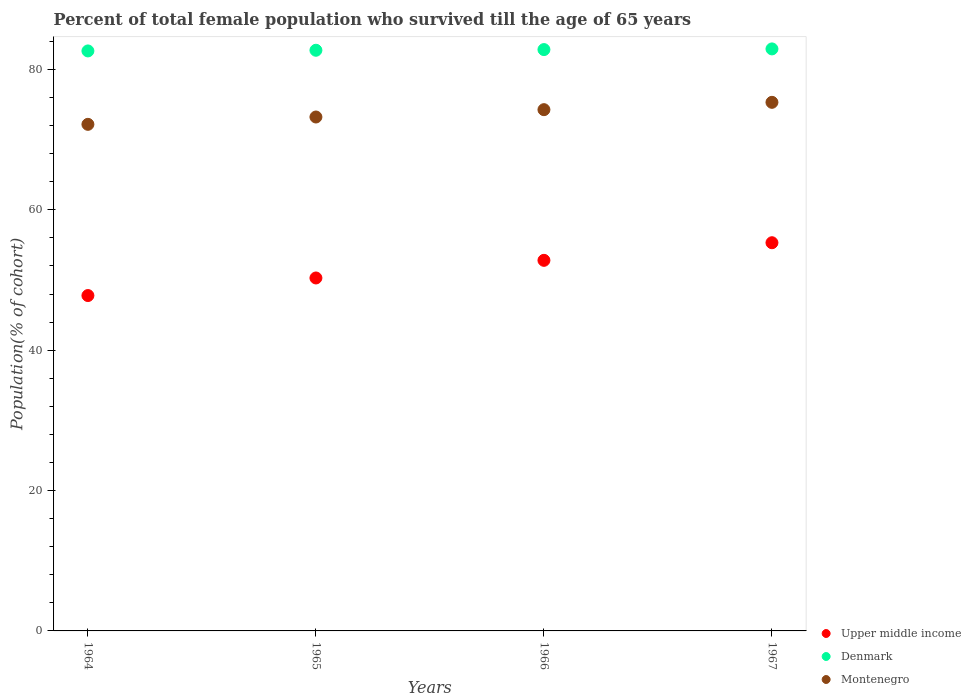How many different coloured dotlines are there?
Offer a very short reply. 3. What is the percentage of total female population who survived till the age of 65 years in Denmark in 1965?
Your answer should be very brief. 82.73. Across all years, what is the maximum percentage of total female population who survived till the age of 65 years in Denmark?
Offer a very short reply. 82.92. Across all years, what is the minimum percentage of total female population who survived till the age of 65 years in Denmark?
Your answer should be very brief. 82.63. In which year was the percentage of total female population who survived till the age of 65 years in Montenegro maximum?
Your answer should be very brief. 1967. In which year was the percentage of total female population who survived till the age of 65 years in Montenegro minimum?
Your answer should be very brief. 1964. What is the total percentage of total female population who survived till the age of 65 years in Denmark in the graph?
Make the answer very short. 331.11. What is the difference between the percentage of total female population who survived till the age of 65 years in Montenegro in 1966 and that in 1967?
Your answer should be very brief. -1.05. What is the difference between the percentage of total female population who survived till the age of 65 years in Upper middle income in 1966 and the percentage of total female population who survived till the age of 65 years in Montenegro in 1964?
Give a very brief answer. -19.38. What is the average percentage of total female population who survived till the age of 65 years in Upper middle income per year?
Give a very brief answer. 51.54. In the year 1964, what is the difference between the percentage of total female population who survived till the age of 65 years in Montenegro and percentage of total female population who survived till the age of 65 years in Upper middle income?
Ensure brevity in your answer.  24.39. In how many years, is the percentage of total female population who survived till the age of 65 years in Denmark greater than 32 %?
Keep it short and to the point. 4. What is the ratio of the percentage of total female population who survived till the age of 65 years in Montenegro in 1964 to that in 1967?
Keep it short and to the point. 0.96. Is the percentage of total female population who survived till the age of 65 years in Denmark in 1965 less than that in 1966?
Offer a very short reply. Yes. Is the difference between the percentage of total female population who survived till the age of 65 years in Montenegro in 1964 and 1967 greater than the difference between the percentage of total female population who survived till the age of 65 years in Upper middle income in 1964 and 1967?
Provide a succinct answer. Yes. What is the difference between the highest and the second highest percentage of total female population who survived till the age of 65 years in Montenegro?
Give a very brief answer. 1.05. What is the difference between the highest and the lowest percentage of total female population who survived till the age of 65 years in Montenegro?
Give a very brief answer. 3.14. Is it the case that in every year, the sum of the percentage of total female population who survived till the age of 65 years in Denmark and percentage of total female population who survived till the age of 65 years in Montenegro  is greater than the percentage of total female population who survived till the age of 65 years in Upper middle income?
Your answer should be compact. Yes. How many dotlines are there?
Keep it short and to the point. 3. How many years are there in the graph?
Keep it short and to the point. 4. What is the difference between two consecutive major ticks on the Y-axis?
Keep it short and to the point. 20. Does the graph contain grids?
Offer a terse response. No. How many legend labels are there?
Offer a terse response. 3. How are the legend labels stacked?
Keep it short and to the point. Vertical. What is the title of the graph?
Provide a succinct answer. Percent of total female population who survived till the age of 65 years. What is the label or title of the X-axis?
Your answer should be compact. Years. What is the label or title of the Y-axis?
Offer a terse response. Population(% of cohort). What is the Population(% of cohort) of Upper middle income in 1964?
Your response must be concise. 47.78. What is the Population(% of cohort) of Denmark in 1964?
Give a very brief answer. 82.63. What is the Population(% of cohort) in Montenegro in 1964?
Make the answer very short. 72.17. What is the Population(% of cohort) of Upper middle income in 1965?
Offer a terse response. 50.29. What is the Population(% of cohort) in Denmark in 1965?
Keep it short and to the point. 82.73. What is the Population(% of cohort) in Montenegro in 1965?
Offer a very short reply. 73.22. What is the Population(% of cohort) of Upper middle income in 1966?
Your answer should be very brief. 52.8. What is the Population(% of cohort) of Denmark in 1966?
Make the answer very short. 82.82. What is the Population(% of cohort) in Montenegro in 1966?
Provide a short and direct response. 74.26. What is the Population(% of cohort) in Upper middle income in 1967?
Offer a terse response. 55.31. What is the Population(% of cohort) of Denmark in 1967?
Give a very brief answer. 82.92. What is the Population(% of cohort) in Montenegro in 1967?
Make the answer very short. 75.31. Across all years, what is the maximum Population(% of cohort) in Upper middle income?
Provide a succinct answer. 55.31. Across all years, what is the maximum Population(% of cohort) in Denmark?
Your answer should be compact. 82.92. Across all years, what is the maximum Population(% of cohort) in Montenegro?
Give a very brief answer. 75.31. Across all years, what is the minimum Population(% of cohort) of Upper middle income?
Give a very brief answer. 47.78. Across all years, what is the minimum Population(% of cohort) in Denmark?
Provide a succinct answer. 82.63. Across all years, what is the minimum Population(% of cohort) of Montenegro?
Offer a terse response. 72.17. What is the total Population(% of cohort) of Upper middle income in the graph?
Provide a succinct answer. 206.17. What is the total Population(% of cohort) in Denmark in the graph?
Provide a succinct answer. 331.11. What is the total Population(% of cohort) in Montenegro in the graph?
Provide a short and direct response. 294.97. What is the difference between the Population(% of cohort) of Upper middle income in 1964 and that in 1965?
Give a very brief answer. -2.5. What is the difference between the Population(% of cohort) of Denmark in 1964 and that in 1965?
Your answer should be very brief. -0.1. What is the difference between the Population(% of cohort) in Montenegro in 1964 and that in 1965?
Make the answer very short. -1.05. What is the difference between the Population(% of cohort) of Upper middle income in 1964 and that in 1966?
Make the answer very short. -5.02. What is the difference between the Population(% of cohort) of Denmark in 1964 and that in 1966?
Your response must be concise. -0.19. What is the difference between the Population(% of cohort) of Montenegro in 1964 and that in 1966?
Give a very brief answer. -2.09. What is the difference between the Population(% of cohort) in Upper middle income in 1964 and that in 1967?
Your answer should be compact. -7.53. What is the difference between the Population(% of cohort) in Denmark in 1964 and that in 1967?
Make the answer very short. -0.29. What is the difference between the Population(% of cohort) of Montenegro in 1964 and that in 1967?
Make the answer very short. -3.14. What is the difference between the Population(% of cohort) of Upper middle income in 1965 and that in 1966?
Ensure brevity in your answer.  -2.51. What is the difference between the Population(% of cohort) in Denmark in 1965 and that in 1966?
Offer a very short reply. -0.1. What is the difference between the Population(% of cohort) in Montenegro in 1965 and that in 1966?
Offer a very short reply. -1.05. What is the difference between the Population(% of cohort) in Upper middle income in 1965 and that in 1967?
Offer a very short reply. -5.02. What is the difference between the Population(% of cohort) of Denmark in 1965 and that in 1967?
Ensure brevity in your answer.  -0.19. What is the difference between the Population(% of cohort) of Montenegro in 1965 and that in 1967?
Keep it short and to the point. -2.09. What is the difference between the Population(% of cohort) in Upper middle income in 1966 and that in 1967?
Keep it short and to the point. -2.51. What is the difference between the Population(% of cohort) of Denmark in 1966 and that in 1967?
Your answer should be compact. -0.1. What is the difference between the Population(% of cohort) of Montenegro in 1966 and that in 1967?
Offer a very short reply. -1.05. What is the difference between the Population(% of cohort) in Upper middle income in 1964 and the Population(% of cohort) in Denmark in 1965?
Provide a short and direct response. -34.95. What is the difference between the Population(% of cohort) of Upper middle income in 1964 and the Population(% of cohort) of Montenegro in 1965?
Provide a succinct answer. -25.44. What is the difference between the Population(% of cohort) of Denmark in 1964 and the Population(% of cohort) of Montenegro in 1965?
Give a very brief answer. 9.41. What is the difference between the Population(% of cohort) of Upper middle income in 1964 and the Population(% of cohort) of Denmark in 1966?
Ensure brevity in your answer.  -35.04. What is the difference between the Population(% of cohort) in Upper middle income in 1964 and the Population(% of cohort) in Montenegro in 1966?
Give a very brief answer. -26.48. What is the difference between the Population(% of cohort) in Denmark in 1964 and the Population(% of cohort) in Montenegro in 1966?
Provide a succinct answer. 8.37. What is the difference between the Population(% of cohort) of Upper middle income in 1964 and the Population(% of cohort) of Denmark in 1967?
Offer a very short reply. -35.14. What is the difference between the Population(% of cohort) in Upper middle income in 1964 and the Population(% of cohort) in Montenegro in 1967?
Your response must be concise. -27.53. What is the difference between the Population(% of cohort) of Denmark in 1964 and the Population(% of cohort) of Montenegro in 1967?
Offer a very short reply. 7.32. What is the difference between the Population(% of cohort) of Upper middle income in 1965 and the Population(% of cohort) of Denmark in 1966?
Offer a very short reply. -32.54. What is the difference between the Population(% of cohort) of Upper middle income in 1965 and the Population(% of cohort) of Montenegro in 1966?
Offer a terse response. -23.98. What is the difference between the Population(% of cohort) of Denmark in 1965 and the Population(% of cohort) of Montenegro in 1966?
Give a very brief answer. 8.46. What is the difference between the Population(% of cohort) of Upper middle income in 1965 and the Population(% of cohort) of Denmark in 1967?
Your answer should be very brief. -32.64. What is the difference between the Population(% of cohort) of Upper middle income in 1965 and the Population(% of cohort) of Montenegro in 1967?
Your answer should be very brief. -25.02. What is the difference between the Population(% of cohort) of Denmark in 1965 and the Population(% of cohort) of Montenegro in 1967?
Give a very brief answer. 7.42. What is the difference between the Population(% of cohort) of Upper middle income in 1966 and the Population(% of cohort) of Denmark in 1967?
Offer a very short reply. -30.12. What is the difference between the Population(% of cohort) in Upper middle income in 1966 and the Population(% of cohort) in Montenegro in 1967?
Ensure brevity in your answer.  -22.51. What is the difference between the Population(% of cohort) in Denmark in 1966 and the Population(% of cohort) in Montenegro in 1967?
Provide a short and direct response. 7.52. What is the average Population(% of cohort) of Upper middle income per year?
Make the answer very short. 51.54. What is the average Population(% of cohort) in Denmark per year?
Make the answer very short. 82.78. What is the average Population(% of cohort) of Montenegro per year?
Your answer should be very brief. 73.74. In the year 1964, what is the difference between the Population(% of cohort) of Upper middle income and Population(% of cohort) of Denmark?
Your answer should be very brief. -34.85. In the year 1964, what is the difference between the Population(% of cohort) in Upper middle income and Population(% of cohort) in Montenegro?
Give a very brief answer. -24.39. In the year 1964, what is the difference between the Population(% of cohort) in Denmark and Population(% of cohort) in Montenegro?
Your answer should be compact. 10.46. In the year 1965, what is the difference between the Population(% of cohort) of Upper middle income and Population(% of cohort) of Denmark?
Your answer should be compact. -32.44. In the year 1965, what is the difference between the Population(% of cohort) in Upper middle income and Population(% of cohort) in Montenegro?
Your answer should be very brief. -22.93. In the year 1965, what is the difference between the Population(% of cohort) in Denmark and Population(% of cohort) in Montenegro?
Give a very brief answer. 9.51. In the year 1966, what is the difference between the Population(% of cohort) of Upper middle income and Population(% of cohort) of Denmark?
Offer a very short reply. -30.03. In the year 1966, what is the difference between the Population(% of cohort) of Upper middle income and Population(% of cohort) of Montenegro?
Offer a terse response. -21.47. In the year 1966, what is the difference between the Population(% of cohort) in Denmark and Population(% of cohort) in Montenegro?
Your response must be concise. 8.56. In the year 1967, what is the difference between the Population(% of cohort) of Upper middle income and Population(% of cohort) of Denmark?
Give a very brief answer. -27.61. In the year 1967, what is the difference between the Population(% of cohort) of Upper middle income and Population(% of cohort) of Montenegro?
Offer a terse response. -20. In the year 1967, what is the difference between the Population(% of cohort) of Denmark and Population(% of cohort) of Montenegro?
Keep it short and to the point. 7.61. What is the ratio of the Population(% of cohort) in Upper middle income in 1964 to that in 1965?
Provide a succinct answer. 0.95. What is the ratio of the Population(% of cohort) of Denmark in 1964 to that in 1965?
Offer a very short reply. 1. What is the ratio of the Population(% of cohort) in Montenegro in 1964 to that in 1965?
Your answer should be very brief. 0.99. What is the ratio of the Population(% of cohort) of Upper middle income in 1964 to that in 1966?
Make the answer very short. 0.91. What is the ratio of the Population(% of cohort) of Denmark in 1964 to that in 1966?
Give a very brief answer. 1. What is the ratio of the Population(% of cohort) in Montenegro in 1964 to that in 1966?
Offer a terse response. 0.97. What is the ratio of the Population(% of cohort) in Upper middle income in 1964 to that in 1967?
Your answer should be very brief. 0.86. What is the ratio of the Population(% of cohort) in Denmark in 1964 to that in 1967?
Keep it short and to the point. 1. What is the ratio of the Population(% of cohort) in Montenegro in 1964 to that in 1967?
Keep it short and to the point. 0.96. What is the ratio of the Population(% of cohort) in Denmark in 1965 to that in 1966?
Your response must be concise. 1. What is the ratio of the Population(% of cohort) of Montenegro in 1965 to that in 1966?
Your answer should be compact. 0.99. What is the ratio of the Population(% of cohort) of Upper middle income in 1965 to that in 1967?
Offer a very short reply. 0.91. What is the ratio of the Population(% of cohort) in Denmark in 1965 to that in 1967?
Give a very brief answer. 1. What is the ratio of the Population(% of cohort) in Montenegro in 1965 to that in 1967?
Provide a short and direct response. 0.97. What is the ratio of the Population(% of cohort) of Upper middle income in 1966 to that in 1967?
Provide a short and direct response. 0.95. What is the ratio of the Population(% of cohort) of Denmark in 1966 to that in 1967?
Your response must be concise. 1. What is the ratio of the Population(% of cohort) of Montenegro in 1966 to that in 1967?
Give a very brief answer. 0.99. What is the difference between the highest and the second highest Population(% of cohort) in Upper middle income?
Provide a succinct answer. 2.51. What is the difference between the highest and the second highest Population(% of cohort) of Denmark?
Keep it short and to the point. 0.1. What is the difference between the highest and the second highest Population(% of cohort) in Montenegro?
Offer a very short reply. 1.05. What is the difference between the highest and the lowest Population(% of cohort) of Upper middle income?
Provide a short and direct response. 7.53. What is the difference between the highest and the lowest Population(% of cohort) of Denmark?
Provide a succinct answer. 0.29. What is the difference between the highest and the lowest Population(% of cohort) of Montenegro?
Keep it short and to the point. 3.14. 